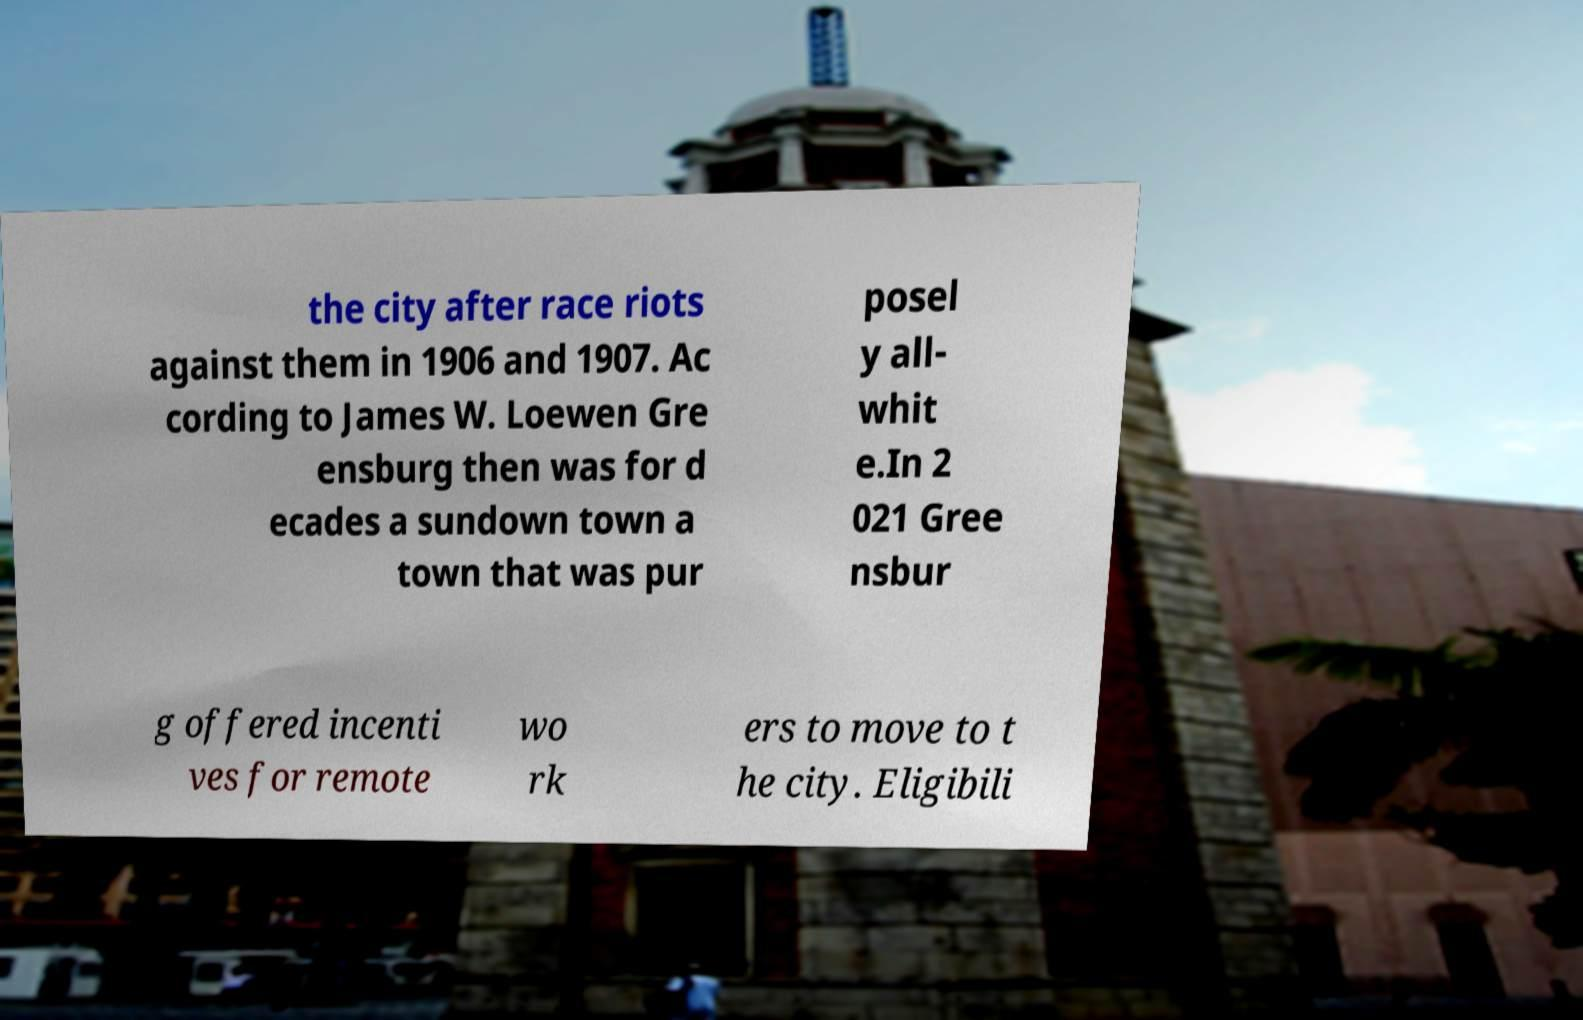Could you assist in decoding the text presented in this image and type it out clearly? the city after race riots against them in 1906 and 1907. Ac cording to James W. Loewen Gre ensburg then was for d ecades a sundown town a town that was pur posel y all- whit e.In 2 021 Gree nsbur g offered incenti ves for remote wo rk ers to move to t he city. Eligibili 